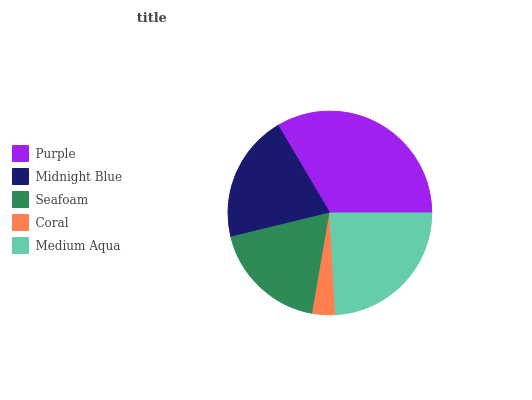Is Coral the minimum?
Answer yes or no. Yes. Is Purple the maximum?
Answer yes or no. Yes. Is Midnight Blue the minimum?
Answer yes or no. No. Is Midnight Blue the maximum?
Answer yes or no. No. Is Purple greater than Midnight Blue?
Answer yes or no. Yes. Is Midnight Blue less than Purple?
Answer yes or no. Yes. Is Midnight Blue greater than Purple?
Answer yes or no. No. Is Purple less than Midnight Blue?
Answer yes or no. No. Is Midnight Blue the high median?
Answer yes or no. Yes. Is Midnight Blue the low median?
Answer yes or no. Yes. Is Medium Aqua the high median?
Answer yes or no. No. Is Coral the low median?
Answer yes or no. No. 